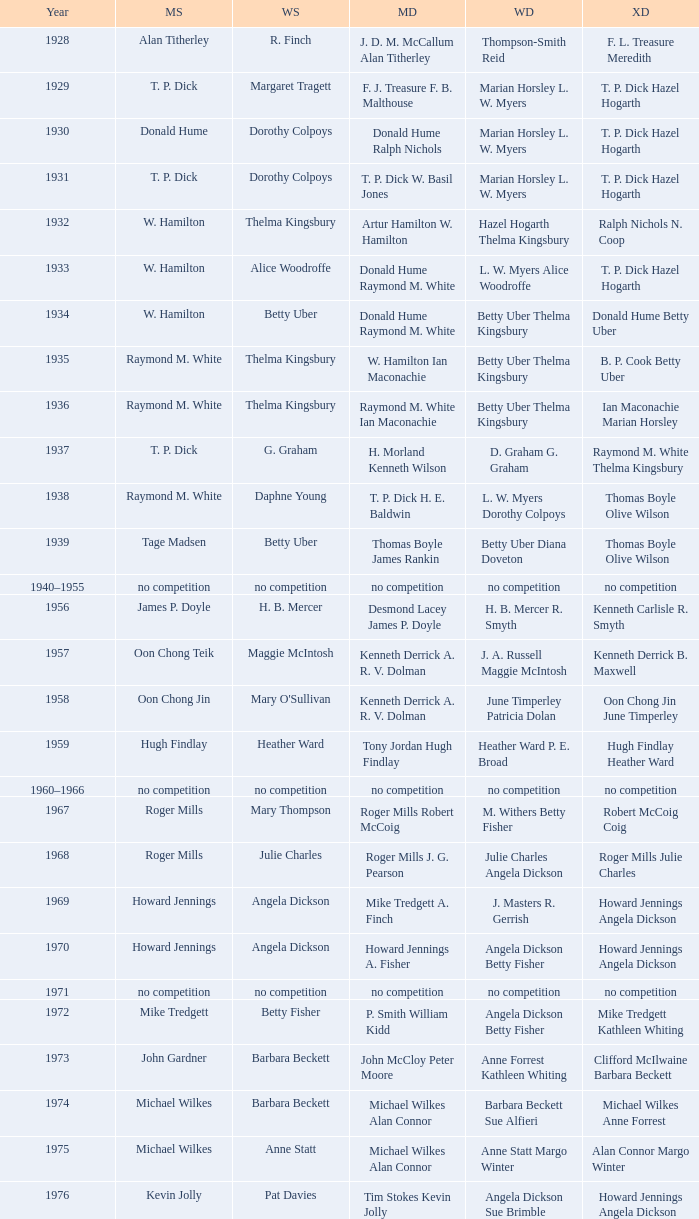Who won the Women's doubles in the year that Billy Gilliland Karen Puttick won the Mixed doubles? Jane Webster Karen Puttick. 